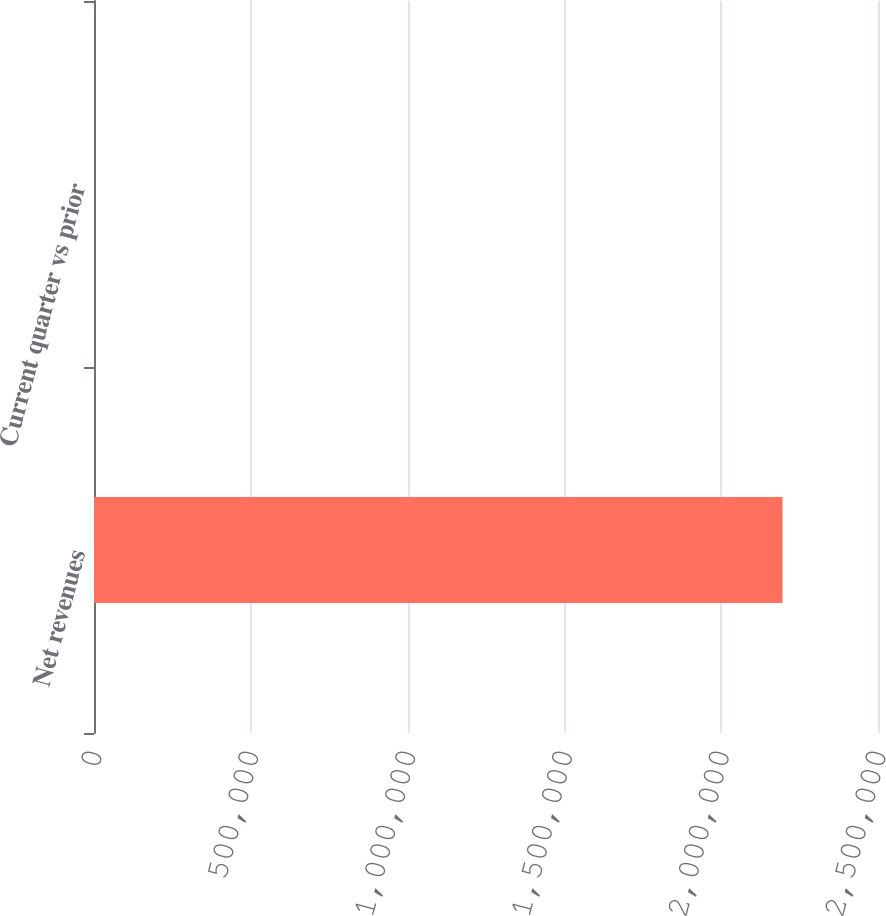<chart> <loc_0><loc_0><loc_500><loc_500><bar_chart><fcel>Net revenues<fcel>Current quarter vs prior<nl><fcel>2.19566e+06<fcel>4<nl></chart> 